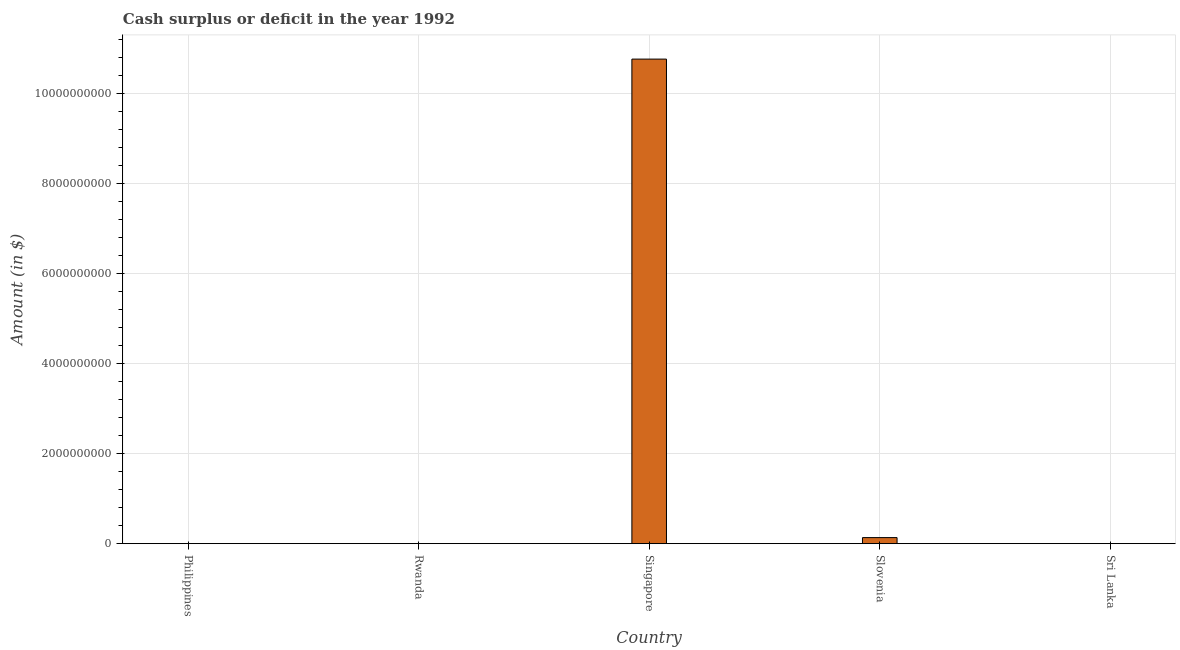What is the title of the graph?
Offer a very short reply. Cash surplus or deficit in the year 1992. What is the label or title of the Y-axis?
Offer a terse response. Amount (in $). Across all countries, what is the maximum cash surplus or deficit?
Your answer should be very brief. 1.08e+1. In which country was the cash surplus or deficit maximum?
Your response must be concise. Singapore. What is the sum of the cash surplus or deficit?
Offer a very short reply. 1.09e+1. What is the average cash surplus or deficit per country?
Your response must be concise. 2.18e+09. What is the median cash surplus or deficit?
Keep it short and to the point. 0. In how many countries, is the cash surplus or deficit greater than 2000000000 $?
Keep it short and to the point. 1. What is the ratio of the cash surplus or deficit in Singapore to that in Slovenia?
Offer a terse response. 80.07. Is the cash surplus or deficit in Singapore less than that in Slovenia?
Keep it short and to the point. No. What is the difference between the highest and the lowest cash surplus or deficit?
Provide a short and direct response. 1.08e+1. In how many countries, is the cash surplus or deficit greater than the average cash surplus or deficit taken over all countries?
Provide a short and direct response. 1. How many bars are there?
Offer a very short reply. 2. Are all the bars in the graph horizontal?
Give a very brief answer. No. What is the difference between two consecutive major ticks on the Y-axis?
Your answer should be compact. 2.00e+09. What is the Amount (in $) in Singapore?
Offer a very short reply. 1.08e+1. What is the Amount (in $) of Slovenia?
Make the answer very short. 1.34e+08. What is the difference between the Amount (in $) in Singapore and Slovenia?
Provide a succinct answer. 1.06e+1. What is the ratio of the Amount (in $) in Singapore to that in Slovenia?
Give a very brief answer. 80.07. 